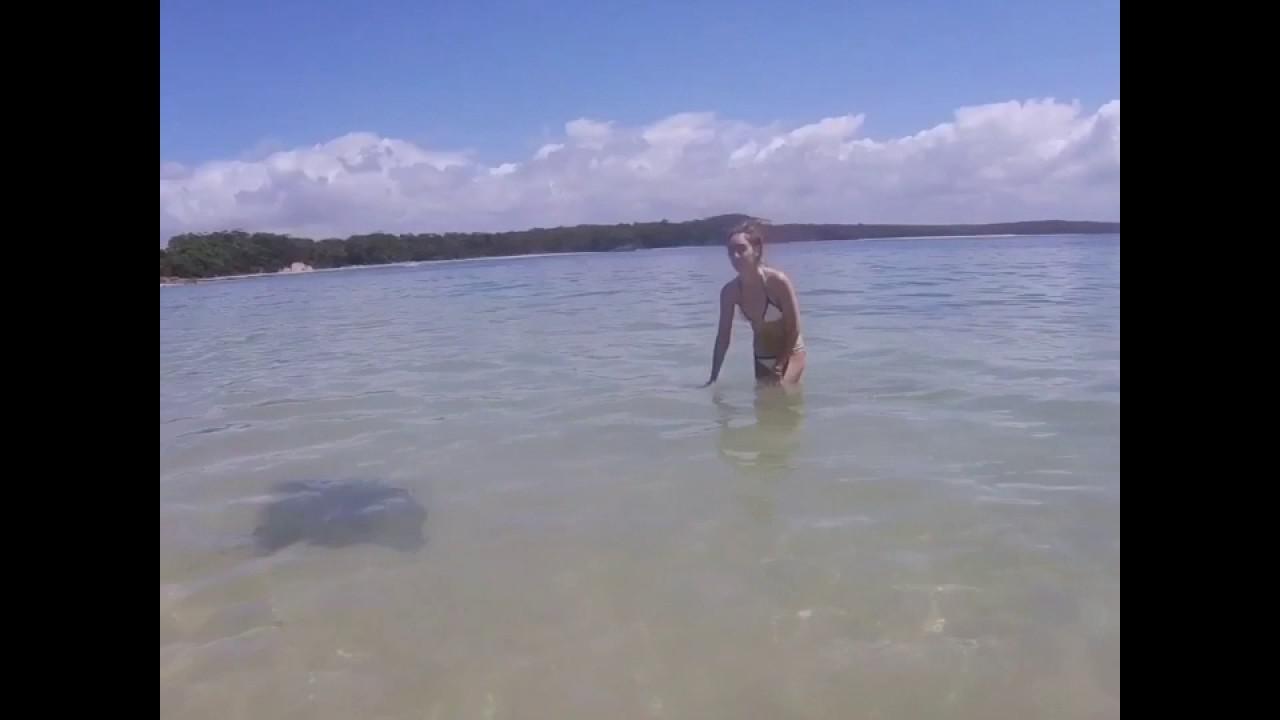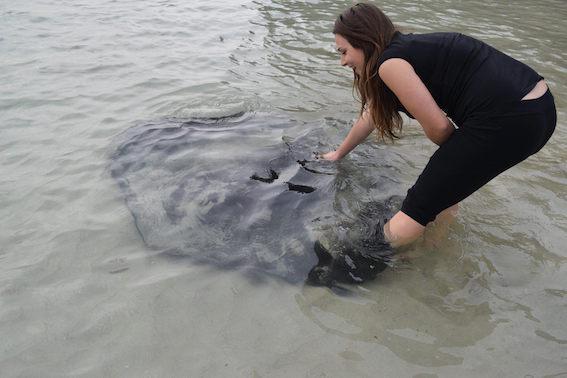The first image is the image on the left, the second image is the image on the right. Given the left and right images, does the statement "There is a person reaching down and touching a stingray." hold true? Answer yes or no. Yes. The first image is the image on the left, the second image is the image on the right. Assess this claim about the two images: "In the right image a human is petting a stingray". Correct or not? Answer yes or no. Yes. 